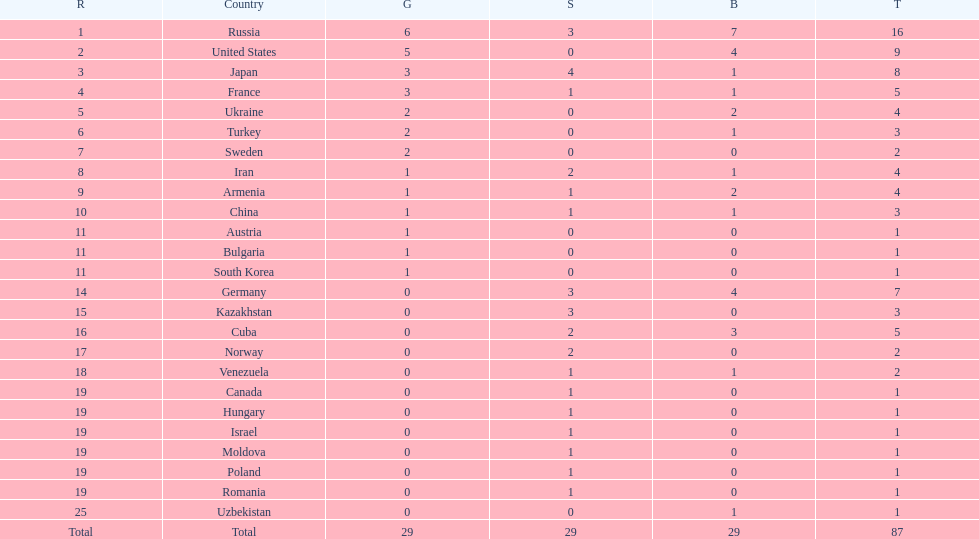Which nation has one gold medal but zero in both silver and bronze? Austria. 